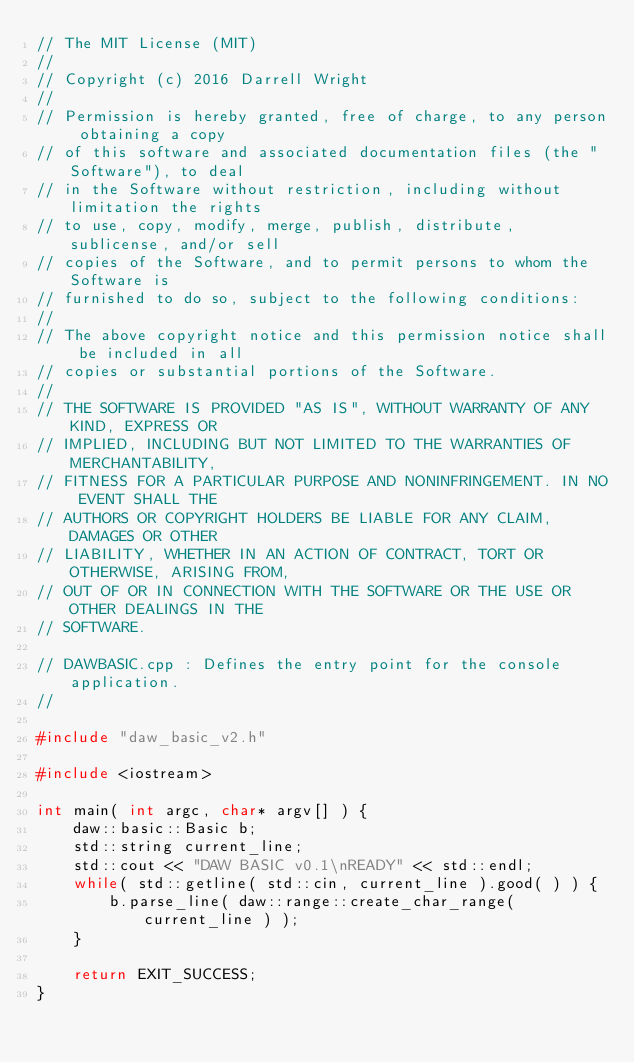<code> <loc_0><loc_0><loc_500><loc_500><_C++_>// The MIT License (MIT)
// 
// Copyright (c) 2016 Darrell Wright
// 
// Permission is hereby granted, free of charge, to any person obtaining a copy
// of this software and associated documentation files (the "Software"), to deal
// in the Software without restriction, including without limitation the rights
// to use, copy, modify, merge, publish, distribute, sublicense, and/or sell
// copies of the Software, and to permit persons to whom the Software is
// furnished to do so, subject to the following conditions:
// 
// The above copyright notice and this permission notice shall be included in all
// copies or substantial portions of the Software.
// 
// THE SOFTWARE IS PROVIDED "AS IS", WITHOUT WARRANTY OF ANY KIND, EXPRESS OR
// IMPLIED, INCLUDING BUT NOT LIMITED TO THE WARRANTIES OF MERCHANTABILITY,
// FITNESS FOR A PARTICULAR PURPOSE AND NONINFRINGEMENT. IN NO EVENT SHALL THE
// AUTHORS OR COPYRIGHT HOLDERS BE LIABLE FOR ANY CLAIM, DAMAGES OR OTHER
// LIABILITY, WHETHER IN AN ACTION OF CONTRACT, TORT OR OTHERWISE, ARISING FROM,
// OUT OF OR IN CONNECTION WITH THE SOFTWARE OR THE USE OR OTHER DEALINGS IN THE
// SOFTWARE.

// DAWBASIC.cpp : Defines the entry point for the console application.
//

#include "daw_basic_v2.h"

#include <iostream>

int main( int argc, char* argv[] ) {
	daw::basic::Basic b;
	std::string current_line;
	std::cout << "DAW BASIC v0.1\nREADY" << std::endl;
	while( std::getline( std::cin, current_line ).good( ) ) {
		b.parse_line( daw::range::create_char_range( current_line ) );
	}

	return EXIT_SUCCESS;
}
</code> 